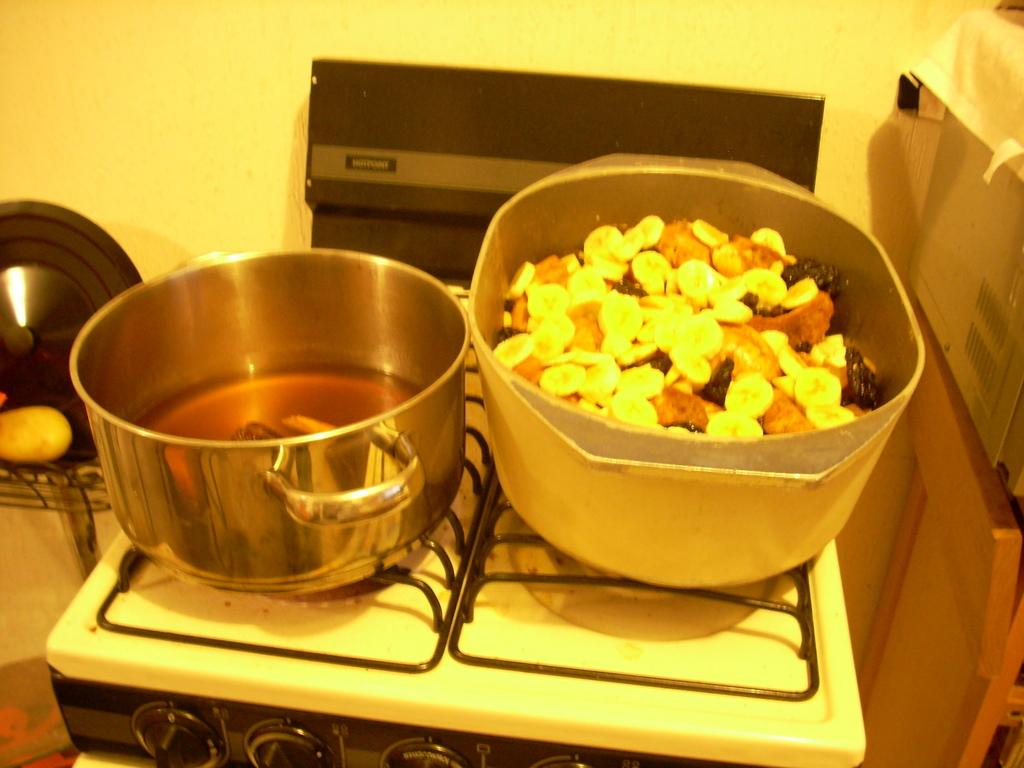What type of appliance is visible in the image? There is a stove in the image. What can be found on the stove? There are bowls in the image. What is being prepared or cooked in the image? There is food in the image. What else can be seen in the image besides the stove and food? There are other objects in the image. What is visible in the background of the image? There is a wall in the background of the image. Can you see any quicksand in the image? No, there is no quicksand present in the image. What scientific experiments are being conducted in the image? There is no indication of any scientific experiments being conducted in the image. 